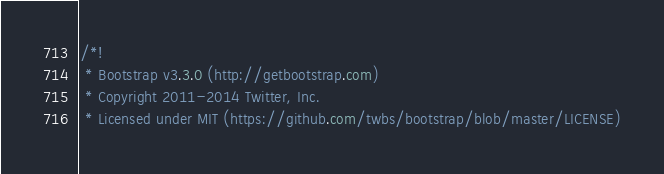Convert code to text. <code><loc_0><loc_0><loc_500><loc_500><_CSS_>/*!
 * Bootstrap v3.3.0 (http://getbootstrap.com)
 * Copyright 2011-2014 Twitter, Inc.
 * Licensed under MIT (https://github.com/twbs/bootstrap/blob/master/LICENSE)</code> 